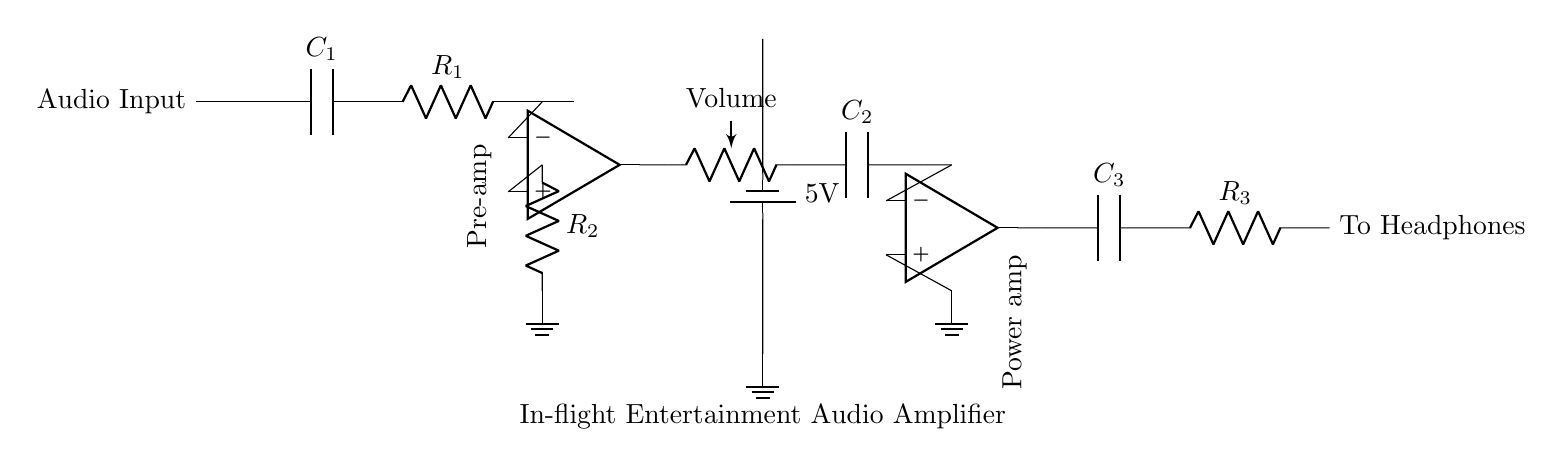What is the component used for volume control? The volume control is represented by a variable resistor labeled "Volume," indicating that it can adjust the level of audio output.
Answer: Volume What is the value of R2? The circuit diagram shows R2 as a resistor but does not indicate a specific value. Therefore, we cannot calculate or state a numerical value for it based solely on the diagram.
Answer: Not specified How many operational amplifiers are in the circuit? The diagram contains two operational amplifiers, one in the pre-amplifier stage and the other in the power amplifier stage, both highlighted in the design.
Answer: Two What is the purpose of capacitor C1? Capacitor C1 is used to block direct current while allowing alternating current (audio signals) to pass through, which is typical in audio amplifiers for signal coupling.
Answer: Coupling What is the total resistance from the input to the ground? To find the total resistance from the input to the ground, you need to consider the components in the circuit. In this case, R1 and R2 are connected in series with the operational amplifier's feedback path. However, the exact numerical total cannot easily be calculated without additional values or context.
Answer: Not calculable without values What is the power supply voltage in this circuit? The circuit provides a 5V power supply to operate the amplifiers, as shown by the battery symbol labeled with this potential.
Answer: 5V What type of amplifier is used in the power amplifier stage? The power amplifier stage uses an operational amplifier, which is designed to amplify the audio signal to drive headphones efficiently.
Answer: Operational amplifier 